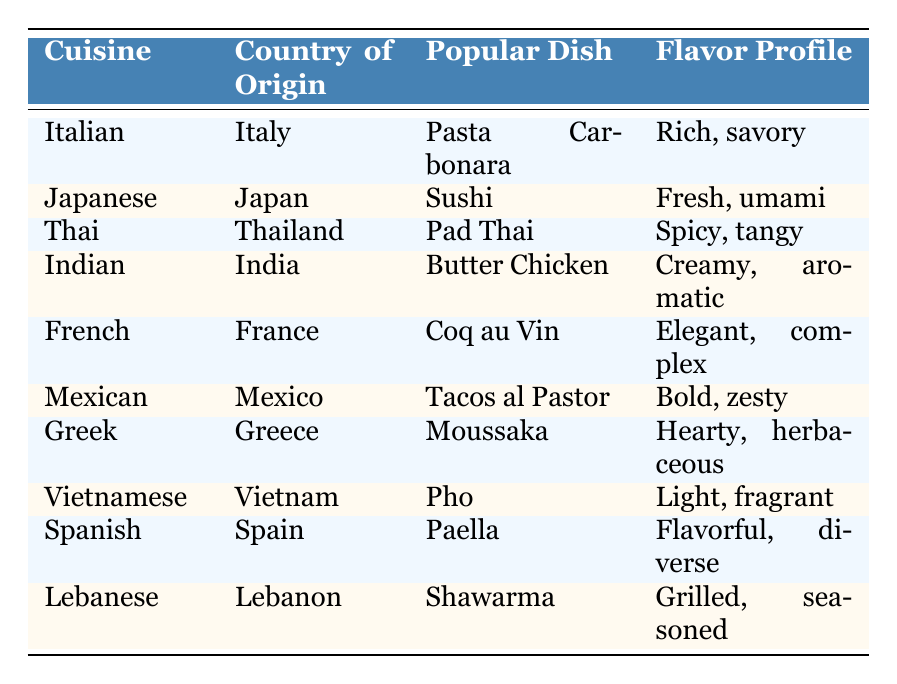What is the popular dish of Italian cuisine? The table lists "Pasta Carbonara" under the Italian cuisine row, which is the popular dish corresponding to Italy.
Answer: Pasta Carbonara Which country is known for Moussaka? According to the table, the country of origin for Moussaka is Greece, as indicated in its row.
Answer: Greece Is the flavor profile of Shawarma grilled and seasoned? The table confirms that the flavor profile of Shawarma is described as "Grilled, seasoned," so the statement is true.
Answer: Yes Which cuisine has a flavor profile described as "Fresh, umami"? Looking at the table, the Japanese cuisine is associated with the flavor profile "Fresh, umami," as seen in its corresponding row.
Answer: Japanese What is the difference in the flavor profiles between Thai and Indian cuisine? Thai cuisine has a flavor profile of "Spicy, tangy," while Indian cuisine has "Creamy, aromatic." The difference highlights the contrasting taste experiences specific to each cuisine.
Answer: Spicy, tangy vs. Creamy, aromatic How many cuisines listed have a flavor profile that includes the word "flavorful"? The table shows that only Spanish cuisine has the flavor profile including "Flavorful, diverse," indicating that it is the only one that meets the criteria.
Answer: 1 Is "Pad Thai" the popular dish for Vietnamese cuisine? According to the table, Pad Thai is listed under the Thai cuisine, and Pho is the popular dish for Vietnamese cuisine, making the statement false.
Answer: No Which cuisine has the richest flavor profile? Comparing the flavor profiles, "Rich, savory" associated with Italian cuisine can be interpreted as richer than others, thus indicating it is the highest among the listed options.
Answer: Italian What flavors characterize French cuisine? The table shows that the flavor profile for French cuisine is "Elegant, complex," which describes the taste characteristics of their typical dishes, especially the Coq au Vin mentioned.
Answer: Elegant, complex 